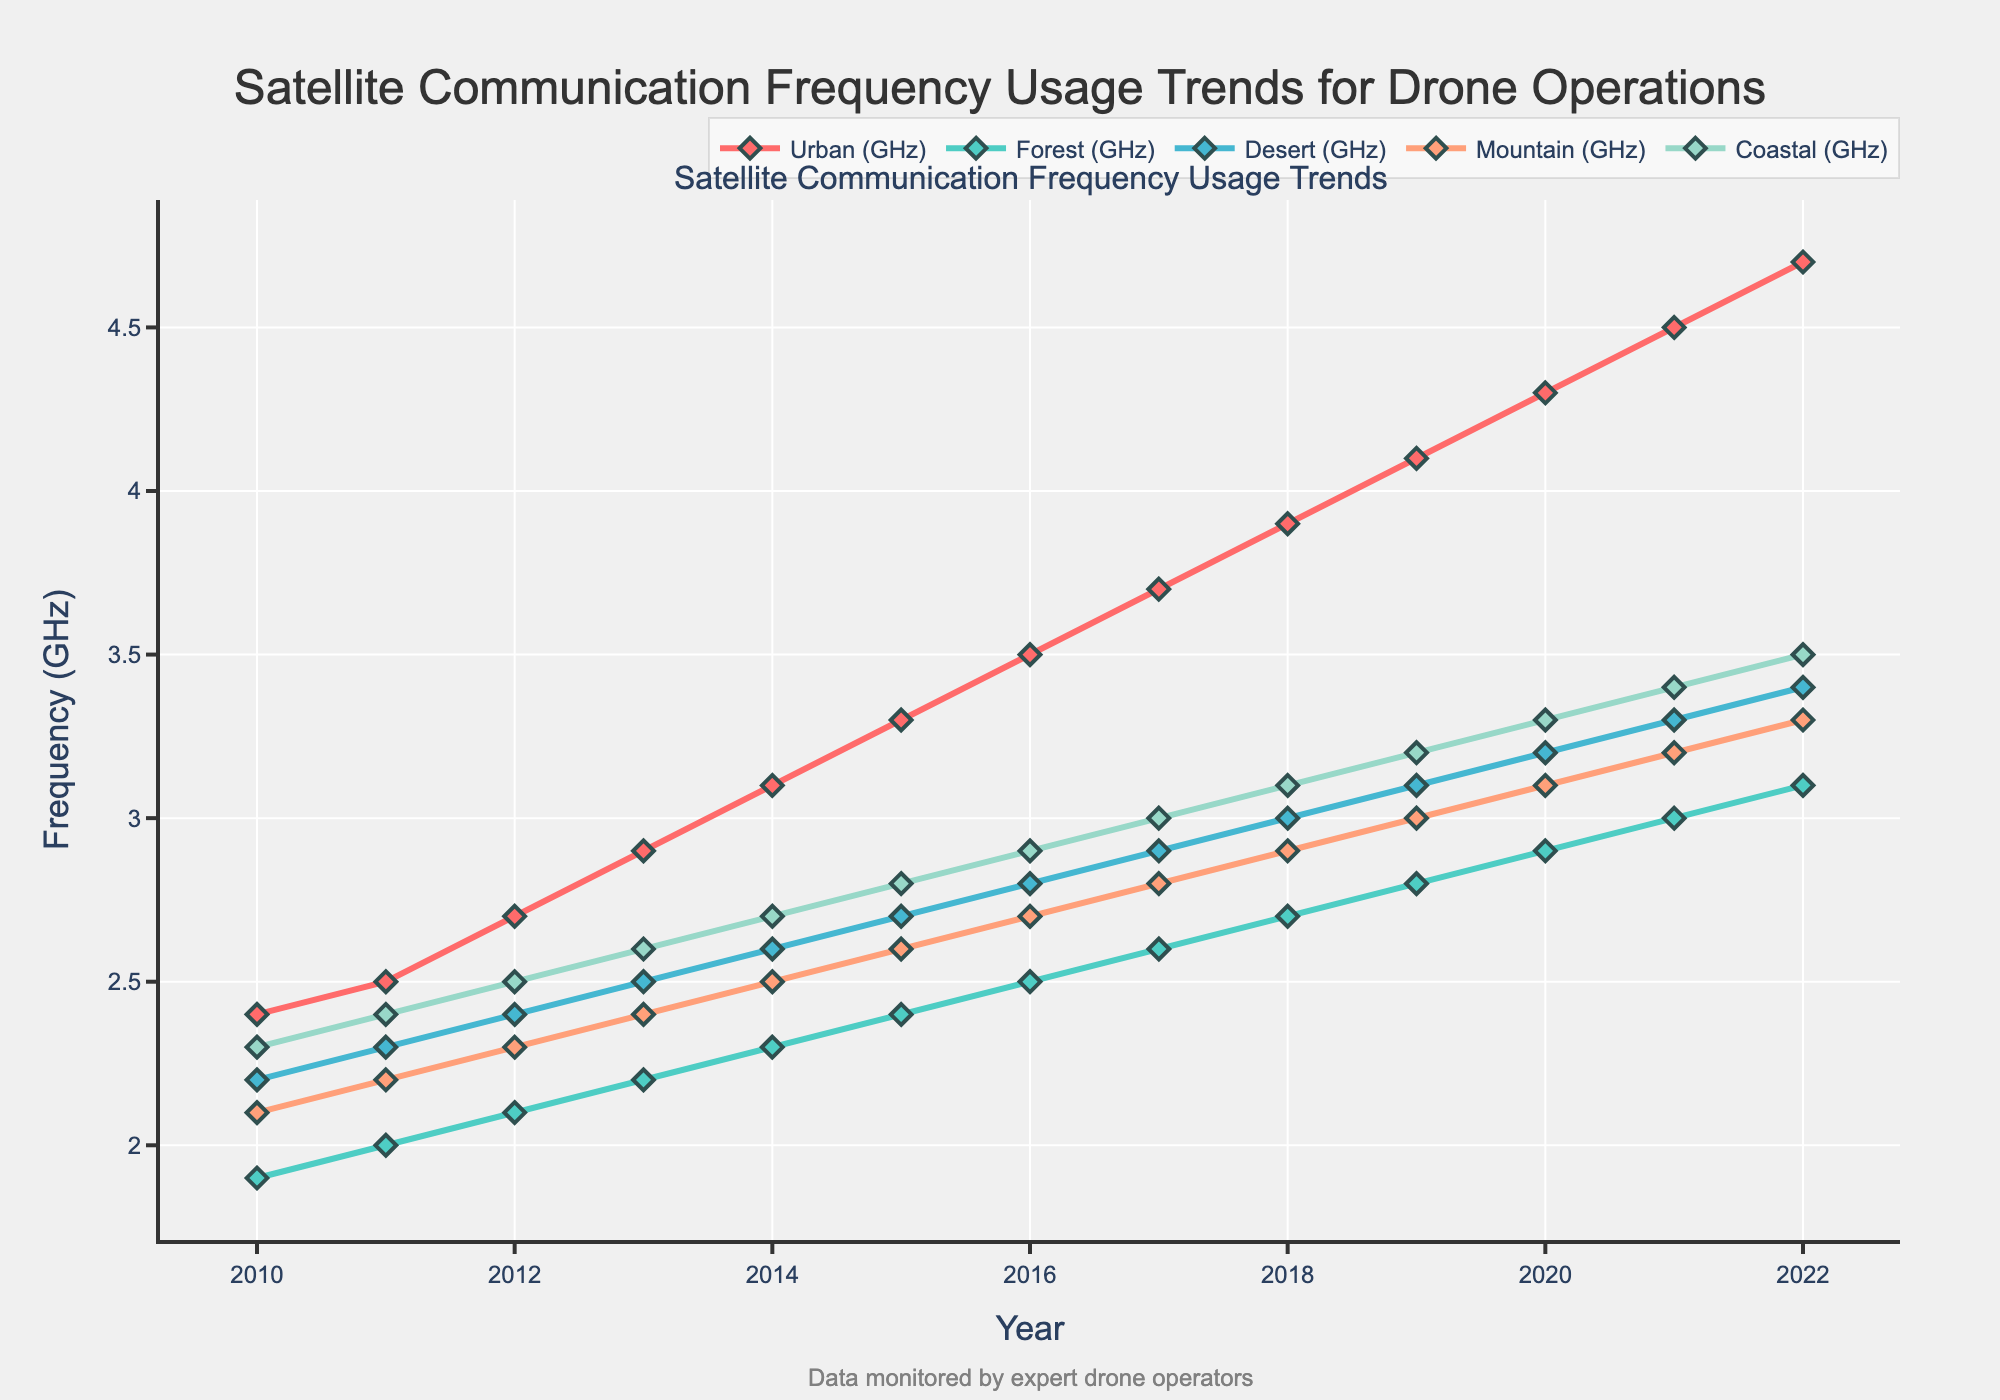What was the frequency in GHz used for drone operations in the Urban terrain in 2018? Locate the line representing the Urban terrain and find the matching data point for the year 2018 on the x-axis. The frequency is 3.9 GHz.
Answer: 3.9 GHz Which terrain shows the lowest frequency usage for drone operations in 2021? For 2021, compare the data points across all terrain lines. The Forest terrain has the lowest frequency of 3.0 GHz.
Answer: Forest How did the frequency for drone operations in the Desert terrain change from 2010 to 2022? Observe the data points for the Desert terrain at the years 2010 and 2022. The frequency increased from 2.2 GHz in 2010 to 3.4 GHz in 2022.
Answer: Increased Which terrain showed the most significant increase in frequency usage from 2010 to 2022? Calculate the difference in frequencies between 2010 and 2022 for each terrain. The Urban terrain had the highest increase from 2.4 GHz to 4.7 GHz, a difference of 2.3 GHz.
Answer: Urban What are the average frequencies used for drone operations in the Mountain terrain between 2010 and 2015? Find the frequencies for the Mountain terrain in each year from 2010 to 2015: 2.1, 2.2, 2.3, 2.4, 2.5, 2.6. Sum them (14.1) and divide by the number of years (6). The average is 14.1/6 ≈ 2.35 GHz.
Answer: 2.35 GHz In which year did the Coastal terrain first surpass the 3.0 GHz frequency mark? Follow the line representing the Coastal terrain and find the first data point where the frequency exceeds 3.0 GHz. This occurs in 2017 (3.0 GHz was reached).
Answer: 2017 Compare the frequency trends between the Forest and Coastal terrains over the years. Both lines show a gradual increase, but the Coastal terrain has a steeper rise. The Forest terrain grows from 1.9 GHz in 2010 to 3.1 GHz in 2022, whereas the Coastal terrain grows from 2.3 GHz to 3.5 GHz in the same period.
Answer: Coastal rises faster What is the difference in frequency usage between the Urban and Forest terrains in 2020? Identify the frequencies for both terrains in 2020: Urban is 4.3 GHz, and Forest is 2.9 GHz. The difference is 4.3 - 2.9 = 1.4 GHz.
Answer: 1.4 GHz 